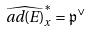<formula> <loc_0><loc_0><loc_500><loc_500>\widehat { a d ( E ) } ^ { * } _ { x } = \mathfrak { p } ^ { \vee }</formula> 